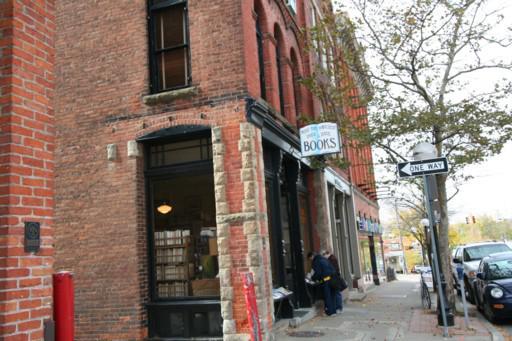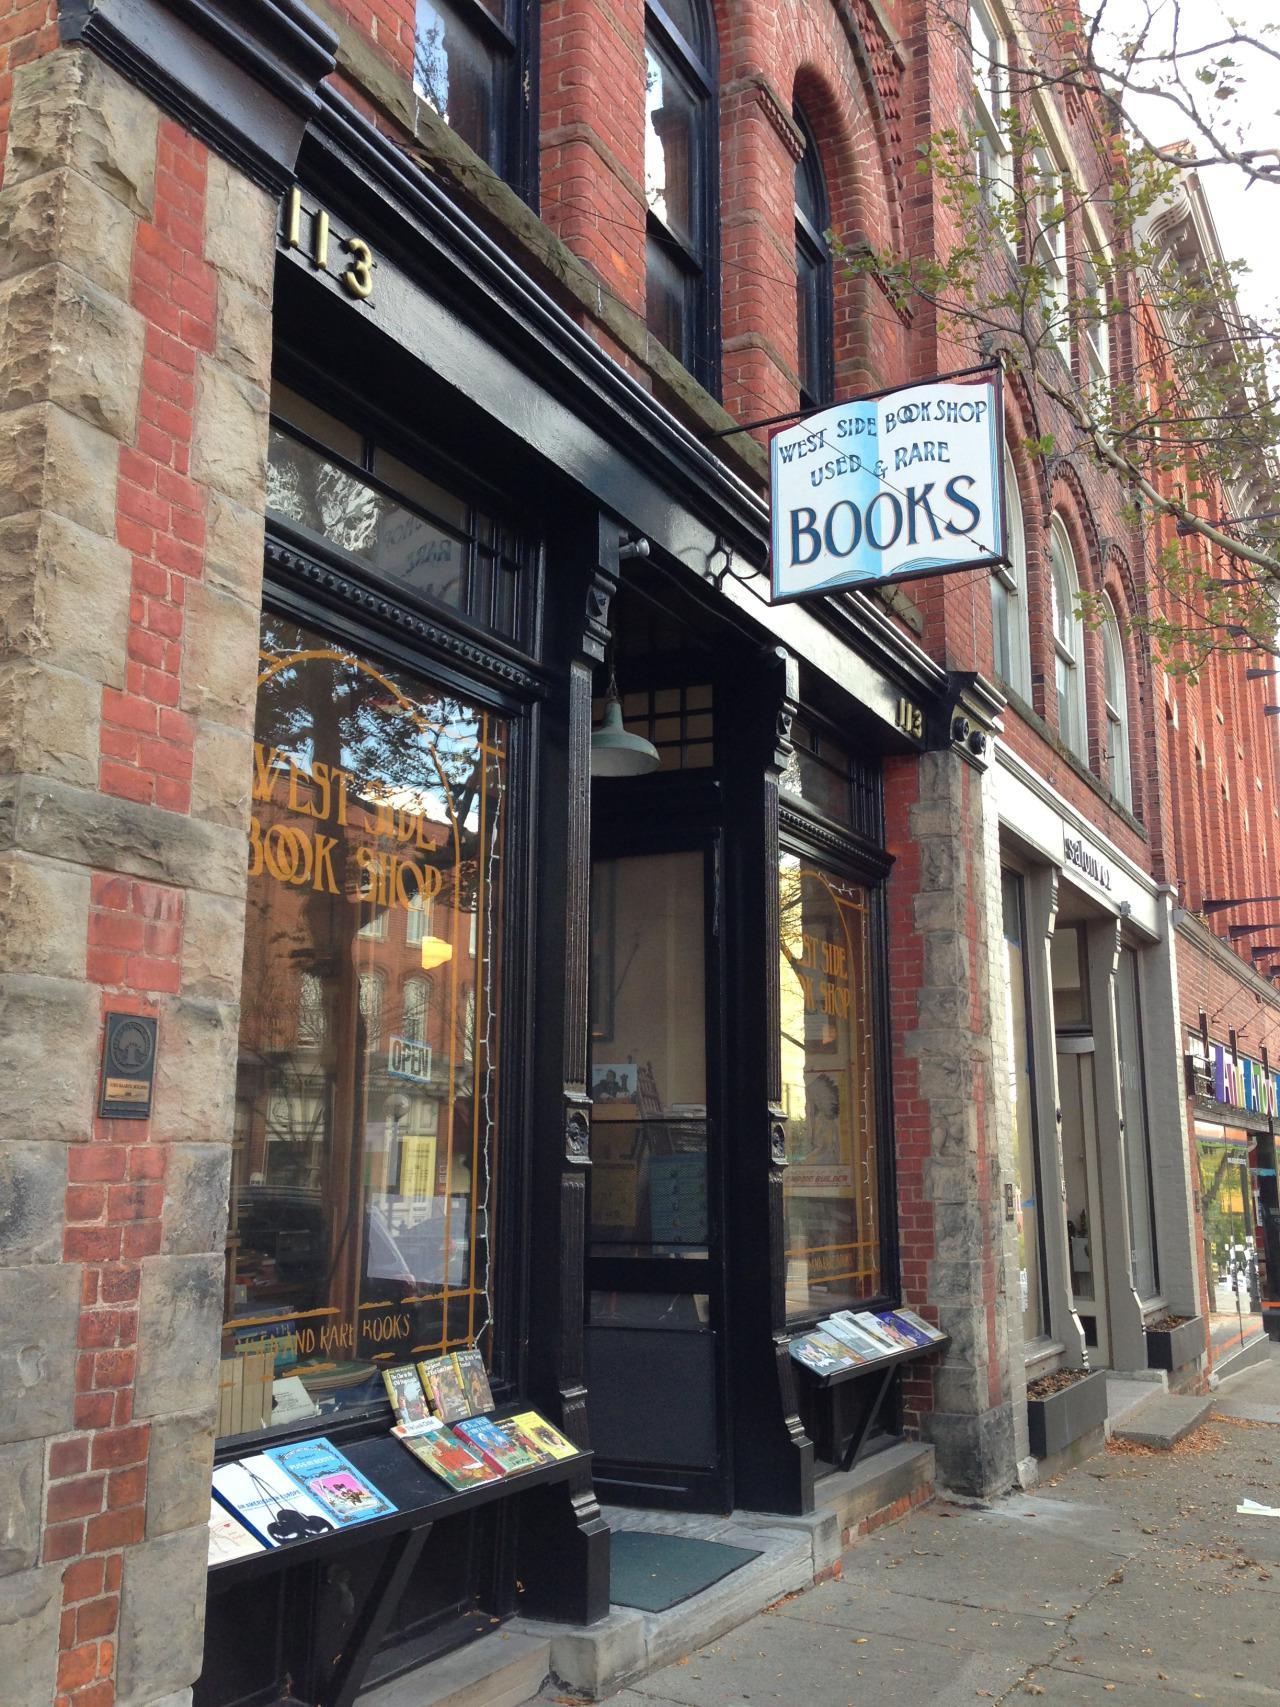The first image is the image on the left, the second image is the image on the right. For the images displayed, is the sentence "A bookstore in a brick building is shown in one image with people on the sidewalk outside, with a second image showing outdoor book racks." factually correct? Answer yes or no. Yes. The first image is the image on the left, the second image is the image on the right. Considering the images on both sides, is "A sign hangs outside the door of a brick bookstore in each of the images." valid? Answer yes or no. Yes. 